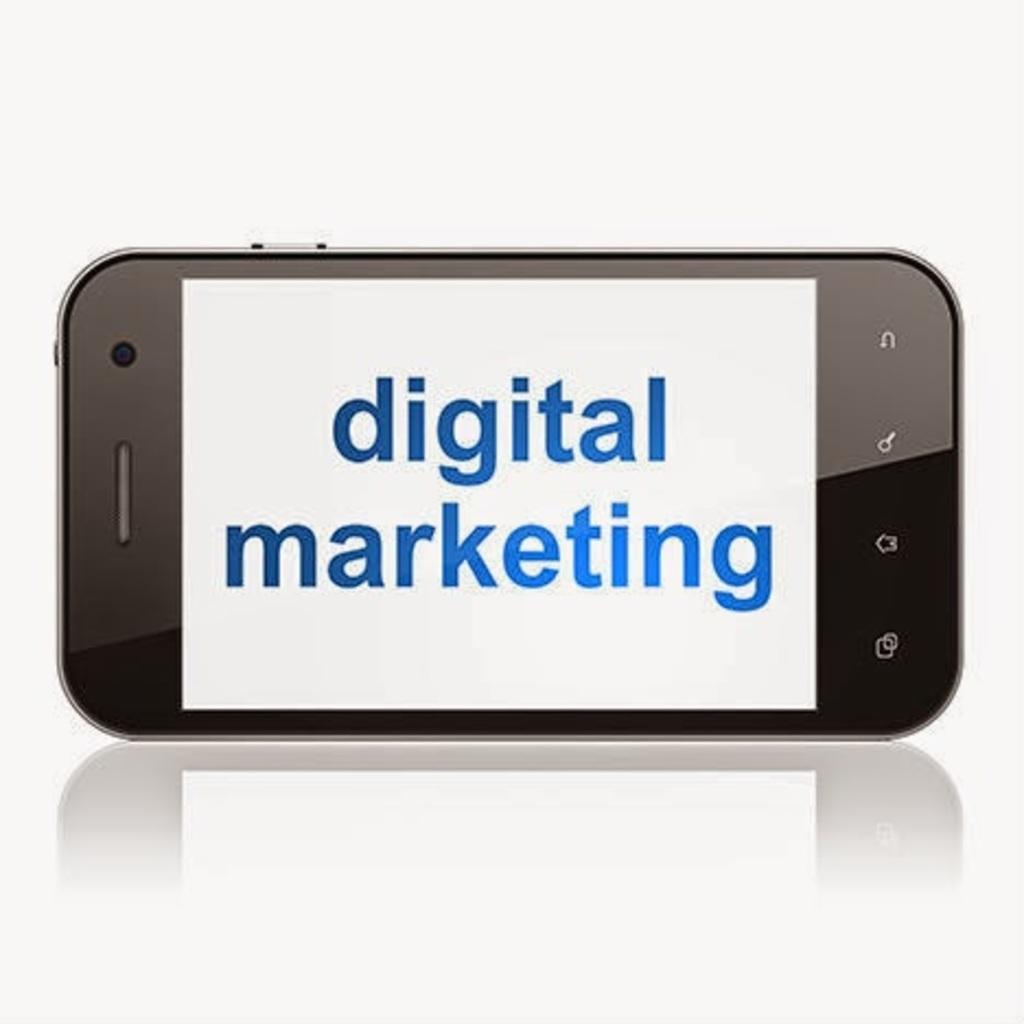What does it say on the phone?
Your answer should be very brief. Digital marketing. What color is the words on the phone?
Your response must be concise. Blue. 